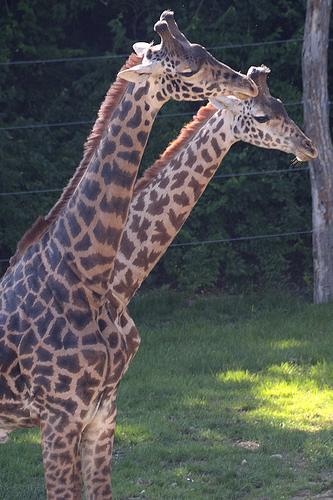<image>
Is there a giraffe on the giraffe? No. The giraffe is not positioned on the giraffe. They may be near each other, but the giraffe is not supported by or resting on top of the giraffe. Is the neck on the grass? No. The neck is not positioned on the grass. They may be near each other, but the neck is not supported by or resting on top of the grass. 